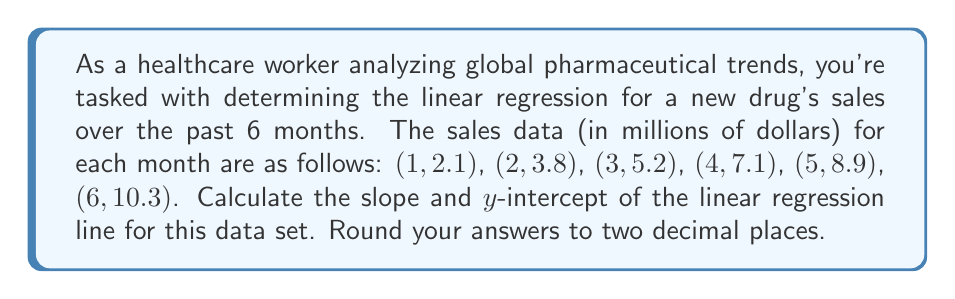Could you help me with this problem? To determine the linear regression, we'll use the least squares method to find the slope (m) and y-intercept (b) of the line y = mx + b.

1. First, let's calculate the means of x and y:
   $\bar{x} = \frac{1+2+3+4+5+6}{6} = 3.5$
   $\bar{y} = \frac{2.1+3.8+5.2+7.1+8.9+10.3}{6} = 6.23$

2. Now, let's calculate the necessary sums:
   $\sum{x_i^2} = 1^2 + 2^2 + 3^2 + 4^2 + 5^2 + 6^2 = 91$
   $\sum{x_iy_i} = 1(2.1) + 2(3.8) + 3(5.2) + 4(7.1) + 5(8.9) + 6(10.3) = 154.4$

3. Calculate the slope (m):
   $$m = \frac{n\sum{x_iy_i} - \sum{x_i}\sum{y_i}}{n\sum{x_i^2} - (\sum{x_i})^2}$$
   $$m = \frac{6(154.4) - (21)(37.4)}{6(91) - (21)^2} = \frac{926.4 - 785.4}{546 - 441} = \frac{141}{105} = 1.34$$

4. Calculate the y-intercept (b):
   $$b = \bar{y} - m\bar{x}$$
   $$b = 6.23 - 1.34(3.5) = 6.23 - 4.69 = 1.54$$

5. Therefore, the linear regression equation is:
   $$y = 1.34x + 1.54$$

Rounding to two decimal places:
Slope (m) = 1.34
Y-intercept (b) = 1.54
Answer: The linear regression equation is y = 1.34x + 1.54, where the slope is 1.34 and the y-intercept is 1.54. 